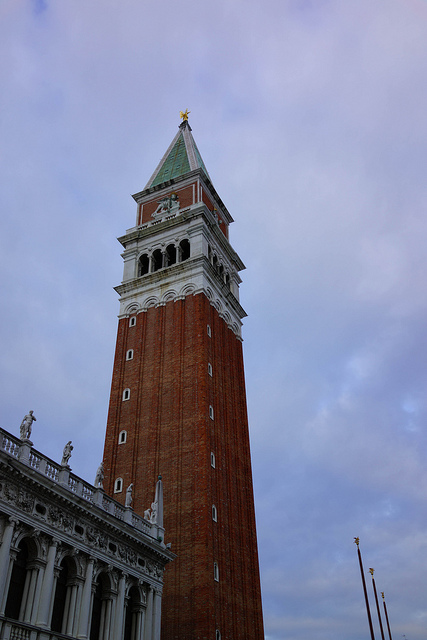<image>Who works in this building? It's not certain who works in this building. It could be government employees or other people. Who works in this building? I don't know who works in this building. It can be government employees, people or no one. 